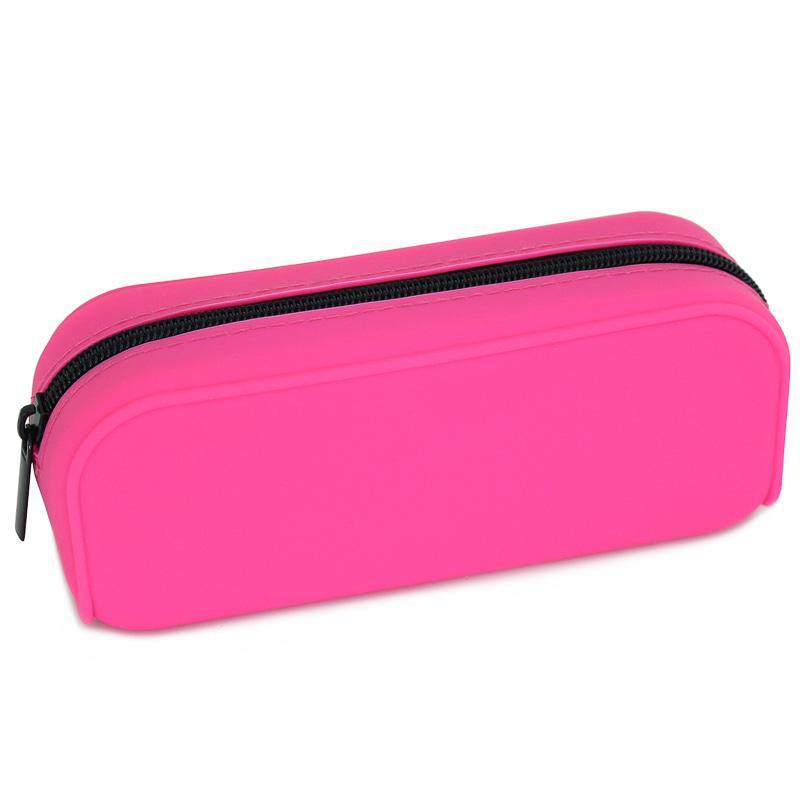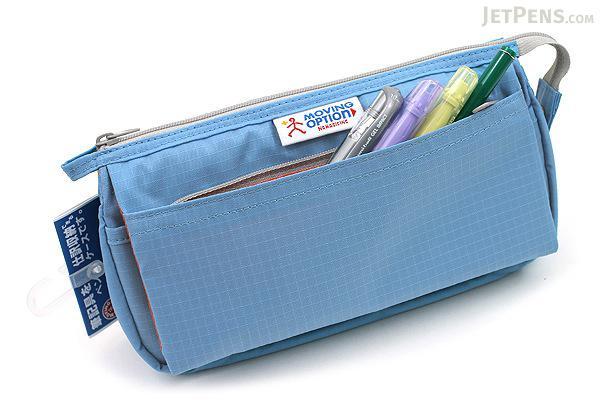The first image is the image on the left, the second image is the image on the right. For the images shown, is this caption "The right image contains a small red hand bag." true? Answer yes or no. No. The first image is the image on the left, the second image is the image on the right. For the images displayed, is the sentence "One image contains a closed red zippered case without any writing implements near it." factually correct? Answer yes or no. No. 